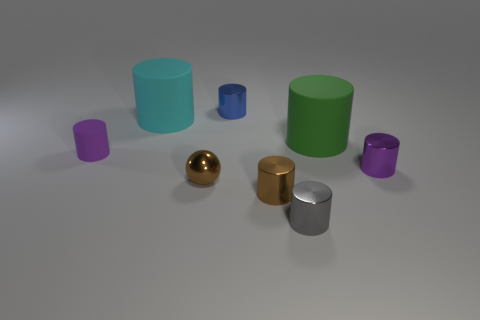Does the purple matte object have the same shape as the large green matte thing? Yes, the purple matte object and the large green matte thing both have cylindrical shapes but they differ in size; the green one is noticeably larger. 